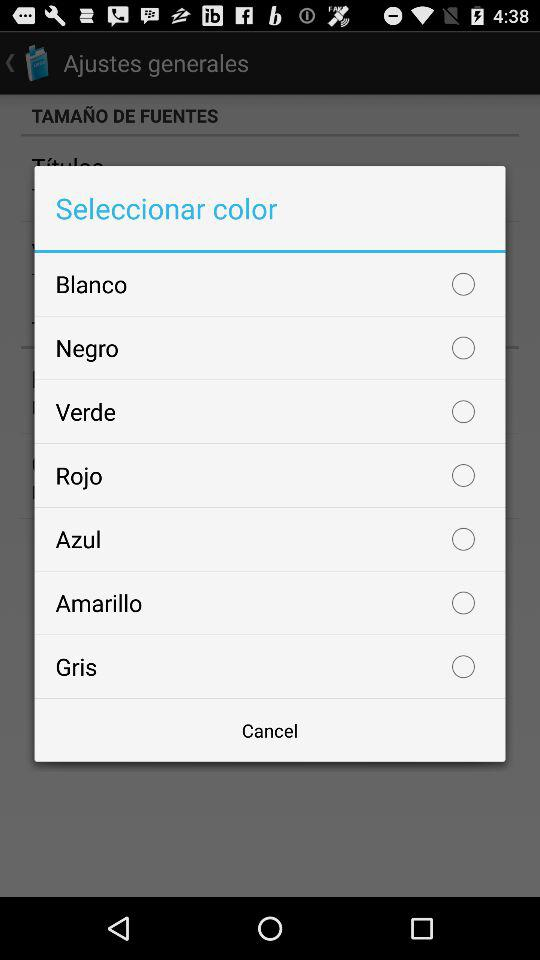How many colors are available to choose from?
Answer the question using a single word or phrase. 7 